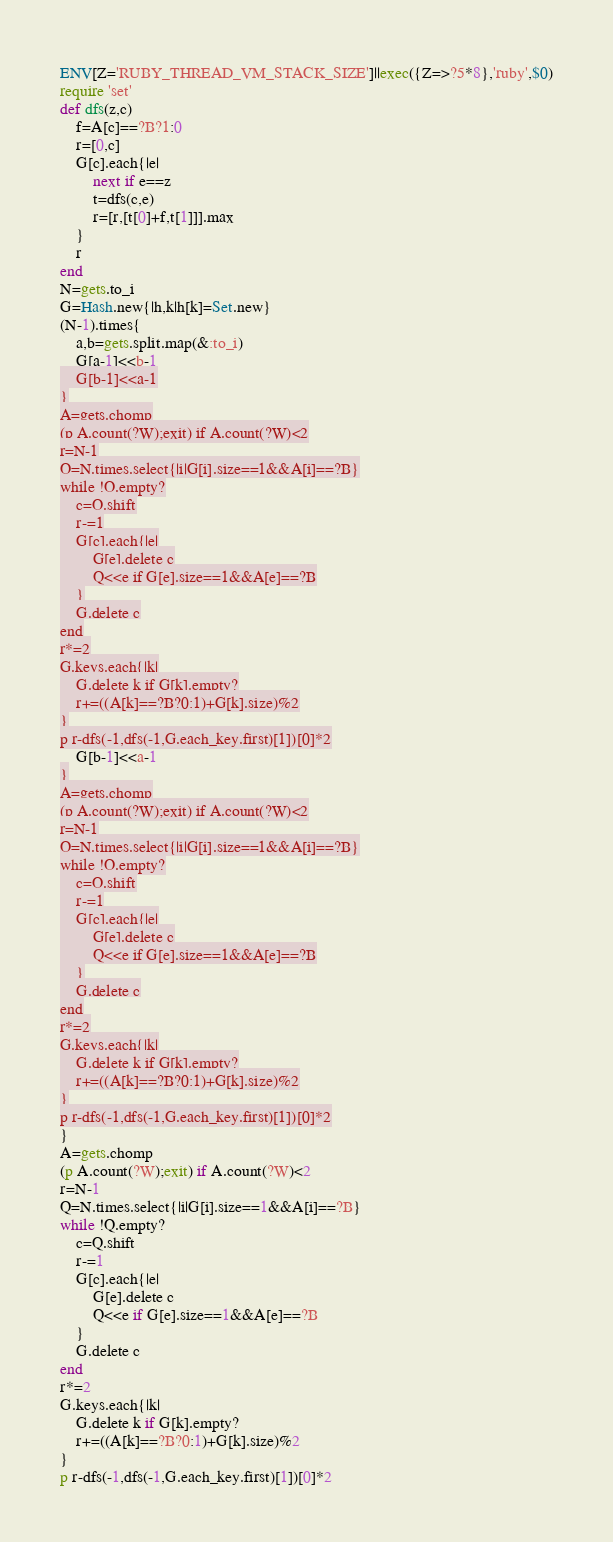<code> <loc_0><loc_0><loc_500><loc_500><_Ruby_>ENV[Z='RUBY_THREAD_VM_STACK_SIZE']||exec({Z=>?5*8},'ruby',$0)
require 'set'
def dfs(z,c)
	f=A[c]==?B?1:0
	r=[0,c]
	G[c].each{|e|
		next if e==z
		t=dfs(c,e)
		r=[r,[t[0]+f,t[1]]].max
	}
	r
end
N=gets.to_i
G=Hash.new{|h,k|h[k]=Set.new}
(N-1).times{
	a,b=gets.split.map(&:to_i)
	G[a-1]<<b-1
	G[b-1]<<a-1
}
A=gets.chomp
(p A.count(?W);exit) if A.count(?W)<2
r=N-1
Q=N.times.select{|i|G[i].size==1&&A[i]==?B}
while !Q.empty?
	c=Q.shift
	r-=1
	G[c].each{|e|
		G[e].delete c
		Q<<e if G[e].size==1&&A[e]==?B
	}
	G.delete c
end
r*=2
G.keys.each{|k|
	G.delete k if G[k].empty?
	r+=((A[k]==?B?0:1)+G[k].size)%2
}
p r-dfs(-1,dfs(-1,G.each_key.first)[1])[0]*2</code> 